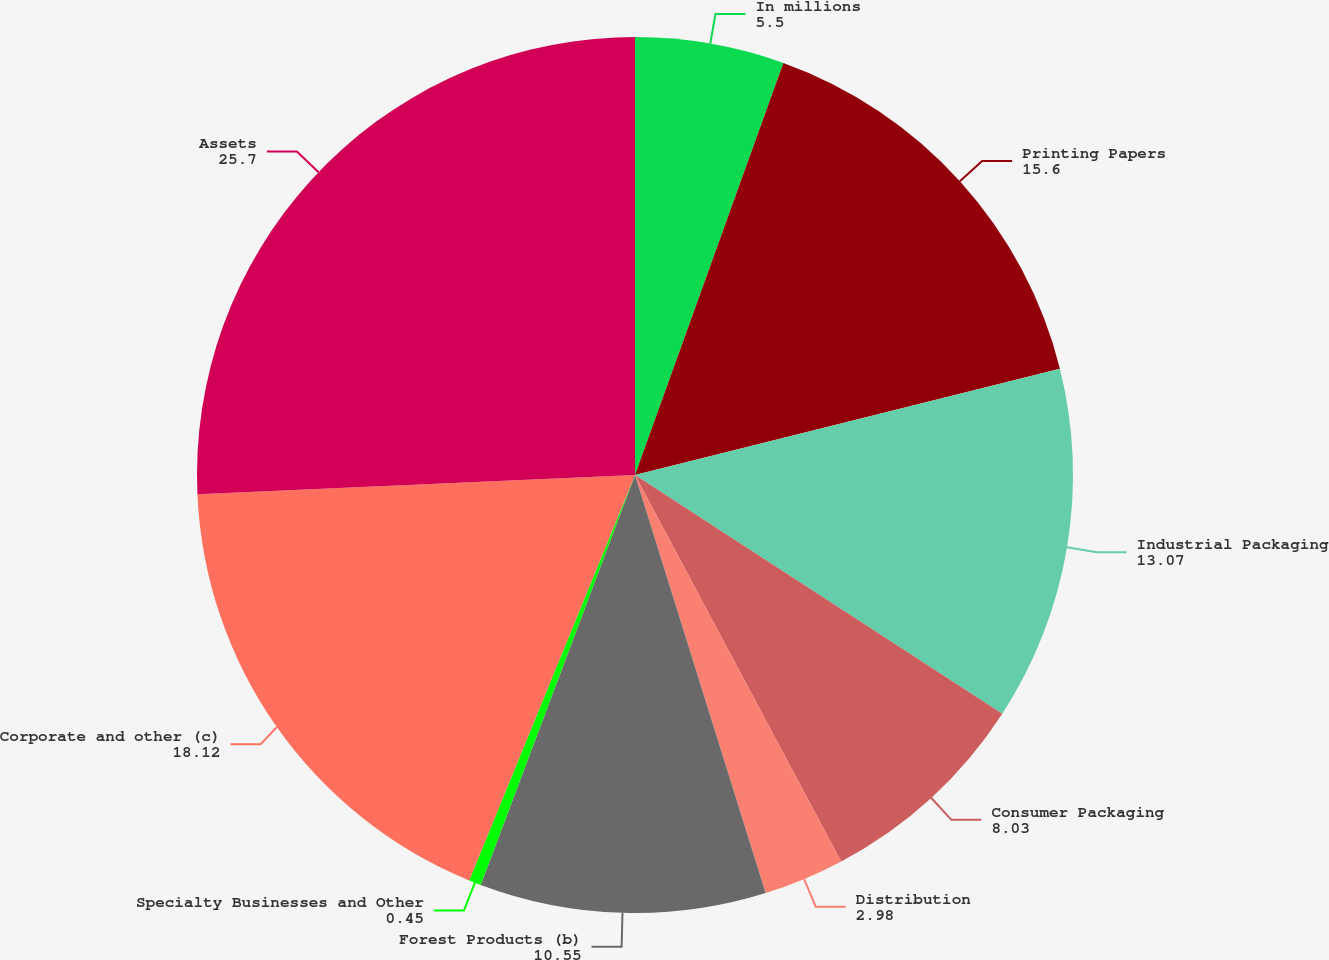Convert chart to OTSL. <chart><loc_0><loc_0><loc_500><loc_500><pie_chart><fcel>In millions<fcel>Printing Papers<fcel>Industrial Packaging<fcel>Consumer Packaging<fcel>Distribution<fcel>Forest Products (b)<fcel>Specialty Businesses and Other<fcel>Corporate and other (c)<fcel>Assets<nl><fcel>5.5%<fcel>15.6%<fcel>13.07%<fcel>8.03%<fcel>2.98%<fcel>10.55%<fcel>0.45%<fcel>18.12%<fcel>25.7%<nl></chart> 